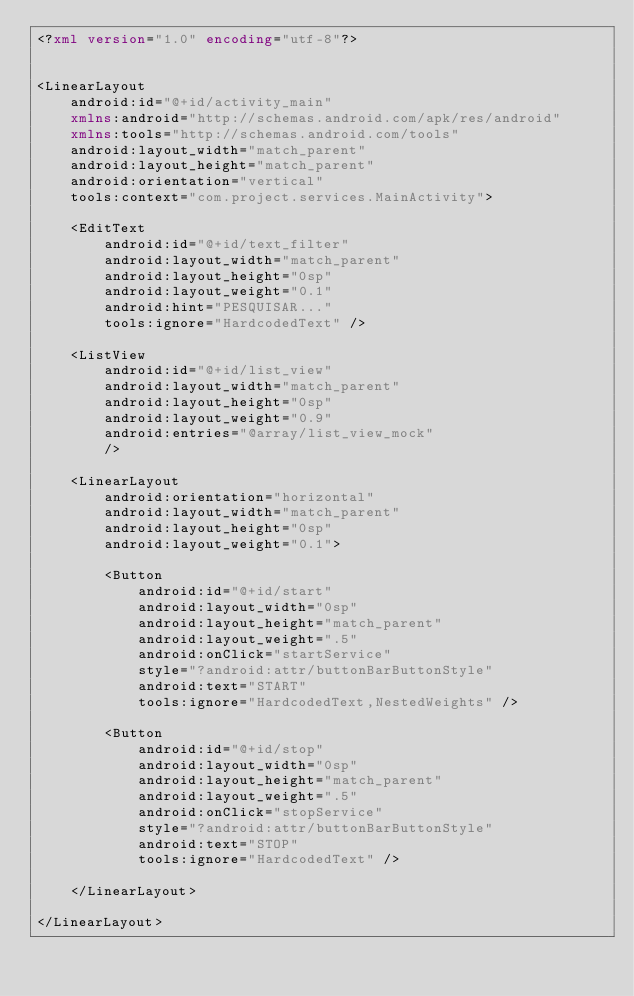<code> <loc_0><loc_0><loc_500><loc_500><_XML_><?xml version="1.0" encoding="utf-8"?>


<LinearLayout
    android:id="@+id/activity_main"
    xmlns:android="http://schemas.android.com/apk/res/android"
    xmlns:tools="http://schemas.android.com/tools"
    android:layout_width="match_parent"
    android:layout_height="match_parent"
    android:orientation="vertical"
    tools:context="com.project.services.MainActivity">

    <EditText
        android:id="@+id/text_filter"
        android:layout_width="match_parent"
        android:layout_height="0sp"
        android:layout_weight="0.1"
        android:hint="PESQUISAR..."
        tools:ignore="HardcodedText" />

    <ListView
        android:id="@+id/list_view"
        android:layout_width="match_parent"
        android:layout_height="0sp"
        android:layout_weight="0.9"
        android:entries="@array/list_view_mock"
        />

    <LinearLayout
        android:orientation="horizontal"
        android:layout_width="match_parent"
        android:layout_height="0sp"
        android:layout_weight="0.1">

        <Button
            android:id="@+id/start"
            android:layout_width="0sp"
            android:layout_height="match_parent"
            android:layout_weight=".5"
            android:onClick="startService"
            style="?android:attr/buttonBarButtonStyle"
            android:text="START"
            tools:ignore="HardcodedText,NestedWeights" />

        <Button
            android:id="@+id/stop"
            android:layout_width="0sp"
            android:layout_height="match_parent"
            android:layout_weight=".5"
            android:onClick="stopService"
            style="?android:attr/buttonBarButtonStyle"
            android:text="STOP"
            tools:ignore="HardcodedText" />

    </LinearLayout>

</LinearLayout></code> 